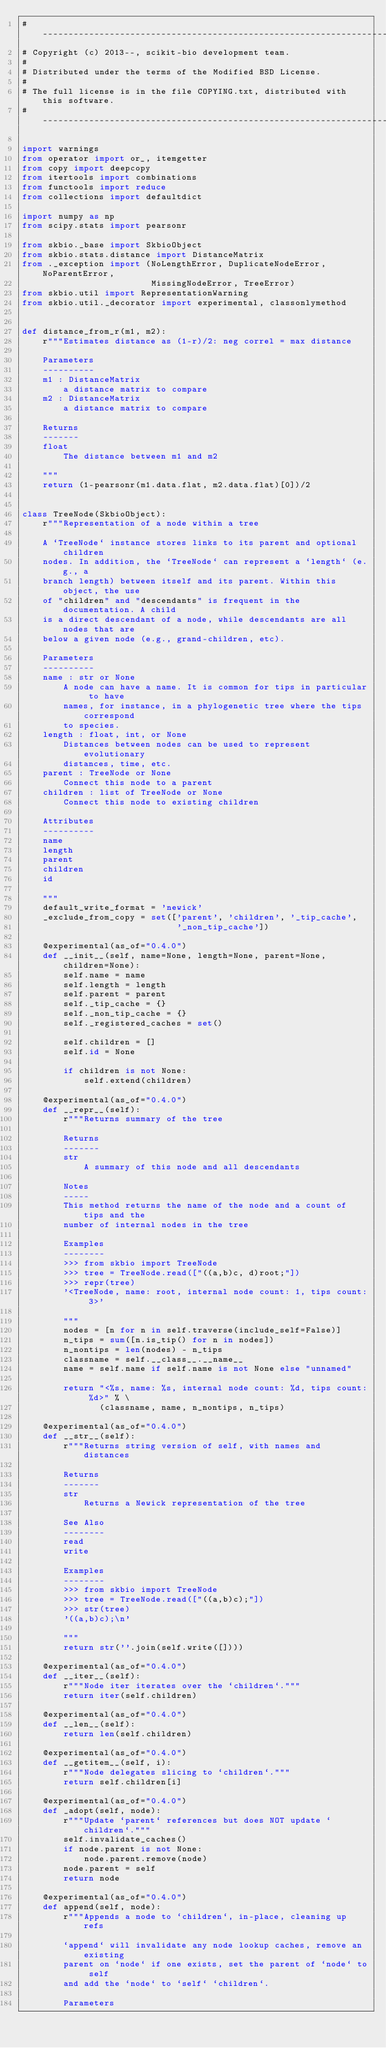Convert code to text. <code><loc_0><loc_0><loc_500><loc_500><_Python_># ----------------------------------------------------------------------------
# Copyright (c) 2013--, scikit-bio development team.
#
# Distributed under the terms of the Modified BSD License.
#
# The full license is in the file COPYING.txt, distributed with this software.
# ----------------------------------------------------------------------------

import warnings
from operator import or_, itemgetter
from copy import deepcopy
from itertools import combinations
from functools import reduce
from collections import defaultdict

import numpy as np
from scipy.stats import pearsonr

from skbio._base import SkbioObject
from skbio.stats.distance import DistanceMatrix
from ._exception import (NoLengthError, DuplicateNodeError, NoParentError,
                         MissingNodeError, TreeError)
from skbio.util import RepresentationWarning
from skbio.util._decorator import experimental, classonlymethod


def distance_from_r(m1, m2):
    r"""Estimates distance as (1-r)/2: neg correl = max distance

    Parameters
    ----------
    m1 : DistanceMatrix
        a distance matrix to compare
    m2 : DistanceMatrix
        a distance matrix to compare

    Returns
    -------
    float
        The distance between m1 and m2

    """
    return (1-pearsonr(m1.data.flat, m2.data.flat)[0])/2


class TreeNode(SkbioObject):
    r"""Representation of a node within a tree

    A `TreeNode` instance stores links to its parent and optional children
    nodes. In addition, the `TreeNode` can represent a `length` (e.g., a
    branch length) between itself and its parent. Within this object, the use
    of "children" and "descendants" is frequent in the documentation. A child
    is a direct descendant of a node, while descendants are all nodes that are
    below a given node (e.g., grand-children, etc).

    Parameters
    ----------
    name : str or None
        A node can have a name. It is common for tips in particular to have
        names, for instance, in a phylogenetic tree where the tips correspond
        to species.
    length : float, int, or None
        Distances between nodes can be used to represent evolutionary
        distances, time, etc.
    parent : TreeNode or None
        Connect this node to a parent
    children : list of TreeNode or None
        Connect this node to existing children

    Attributes
    ----------
    name
    length
    parent
    children
    id

    """
    default_write_format = 'newick'
    _exclude_from_copy = set(['parent', 'children', '_tip_cache',
                              '_non_tip_cache'])

    @experimental(as_of="0.4.0")
    def __init__(self, name=None, length=None, parent=None, children=None):
        self.name = name
        self.length = length
        self.parent = parent
        self._tip_cache = {}
        self._non_tip_cache = {}
        self._registered_caches = set()

        self.children = []
        self.id = None

        if children is not None:
            self.extend(children)

    @experimental(as_of="0.4.0")
    def __repr__(self):
        r"""Returns summary of the tree

        Returns
        -------
        str
            A summary of this node and all descendants

        Notes
        -----
        This method returns the name of the node and a count of tips and the
        number of internal nodes in the tree

        Examples
        --------
        >>> from skbio import TreeNode
        >>> tree = TreeNode.read(["((a,b)c, d)root;"])
        >>> repr(tree)
        '<TreeNode, name: root, internal node count: 1, tips count: 3>'

        """
        nodes = [n for n in self.traverse(include_self=False)]
        n_tips = sum([n.is_tip() for n in nodes])
        n_nontips = len(nodes) - n_tips
        classname = self.__class__.__name__
        name = self.name if self.name is not None else "unnamed"

        return "<%s, name: %s, internal node count: %d, tips count: %d>" % \
               (classname, name, n_nontips, n_tips)

    @experimental(as_of="0.4.0")
    def __str__(self):
        r"""Returns string version of self, with names and distances

        Returns
        -------
        str
            Returns a Newick representation of the tree

        See Also
        --------
        read
        write

        Examples
        --------
        >>> from skbio import TreeNode
        >>> tree = TreeNode.read(["((a,b)c);"])
        >>> str(tree)
        '((a,b)c);\n'

        """
        return str(''.join(self.write([])))

    @experimental(as_of="0.4.0")
    def __iter__(self):
        r"""Node iter iterates over the `children`."""
        return iter(self.children)

    @experimental(as_of="0.4.0")
    def __len__(self):
        return len(self.children)

    @experimental(as_of="0.4.0")
    def __getitem__(self, i):
        r"""Node delegates slicing to `children`."""
        return self.children[i]

    @experimental(as_of="0.4.0")
    def _adopt(self, node):
        r"""Update `parent` references but does NOT update `children`."""
        self.invalidate_caches()
        if node.parent is not None:
            node.parent.remove(node)
        node.parent = self
        return node

    @experimental(as_of="0.4.0")
    def append(self, node):
        r"""Appends a node to `children`, in-place, cleaning up refs

        `append` will invalidate any node lookup caches, remove an existing
        parent on `node` if one exists, set the parent of `node` to self
        and add the `node` to `self` `children`.

        Parameters</code> 